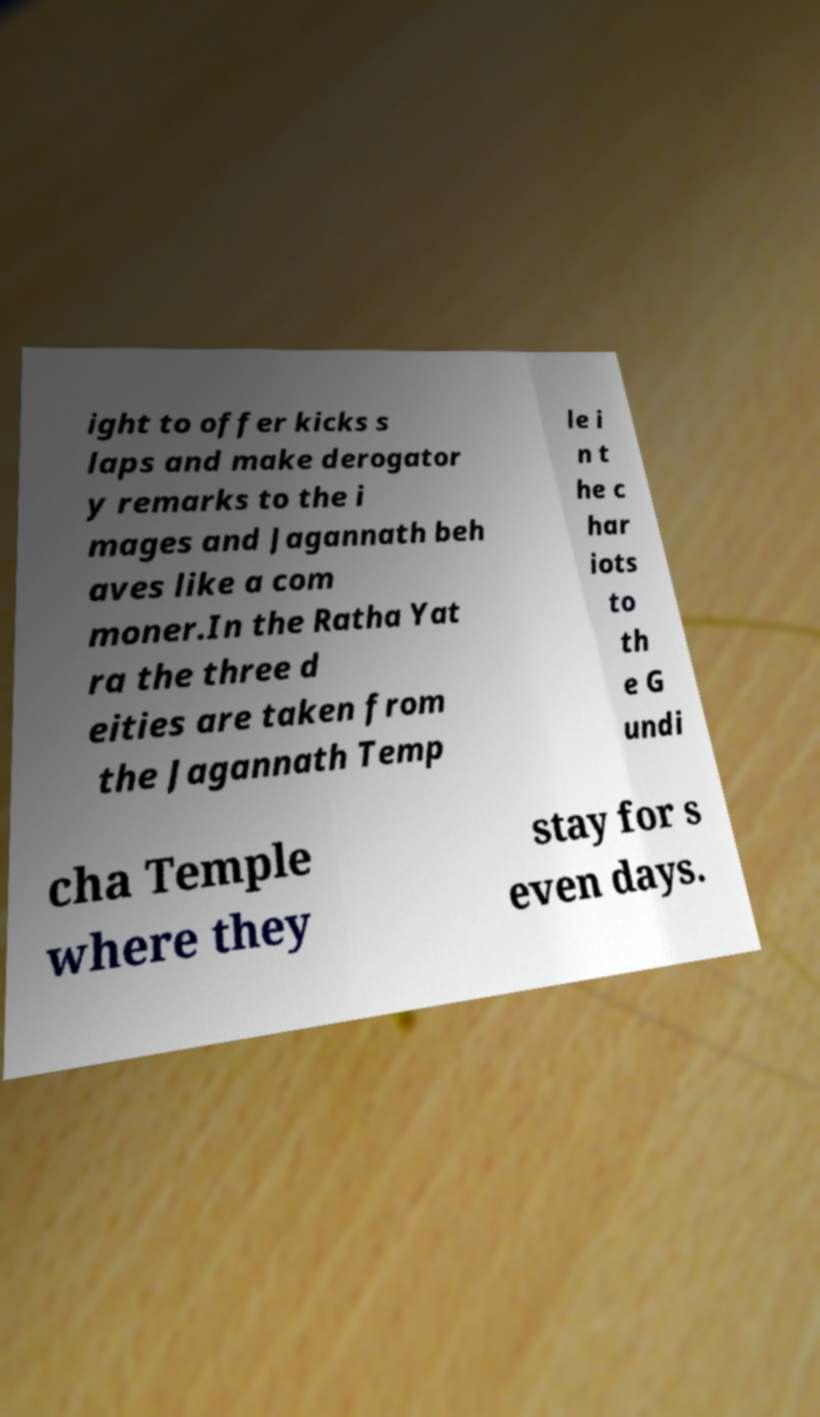Can you accurately transcribe the text from the provided image for me? ight to offer kicks s laps and make derogator y remarks to the i mages and Jagannath beh aves like a com moner.In the Ratha Yat ra the three d eities are taken from the Jagannath Temp le i n t he c har iots to th e G undi cha Temple where they stay for s even days. 